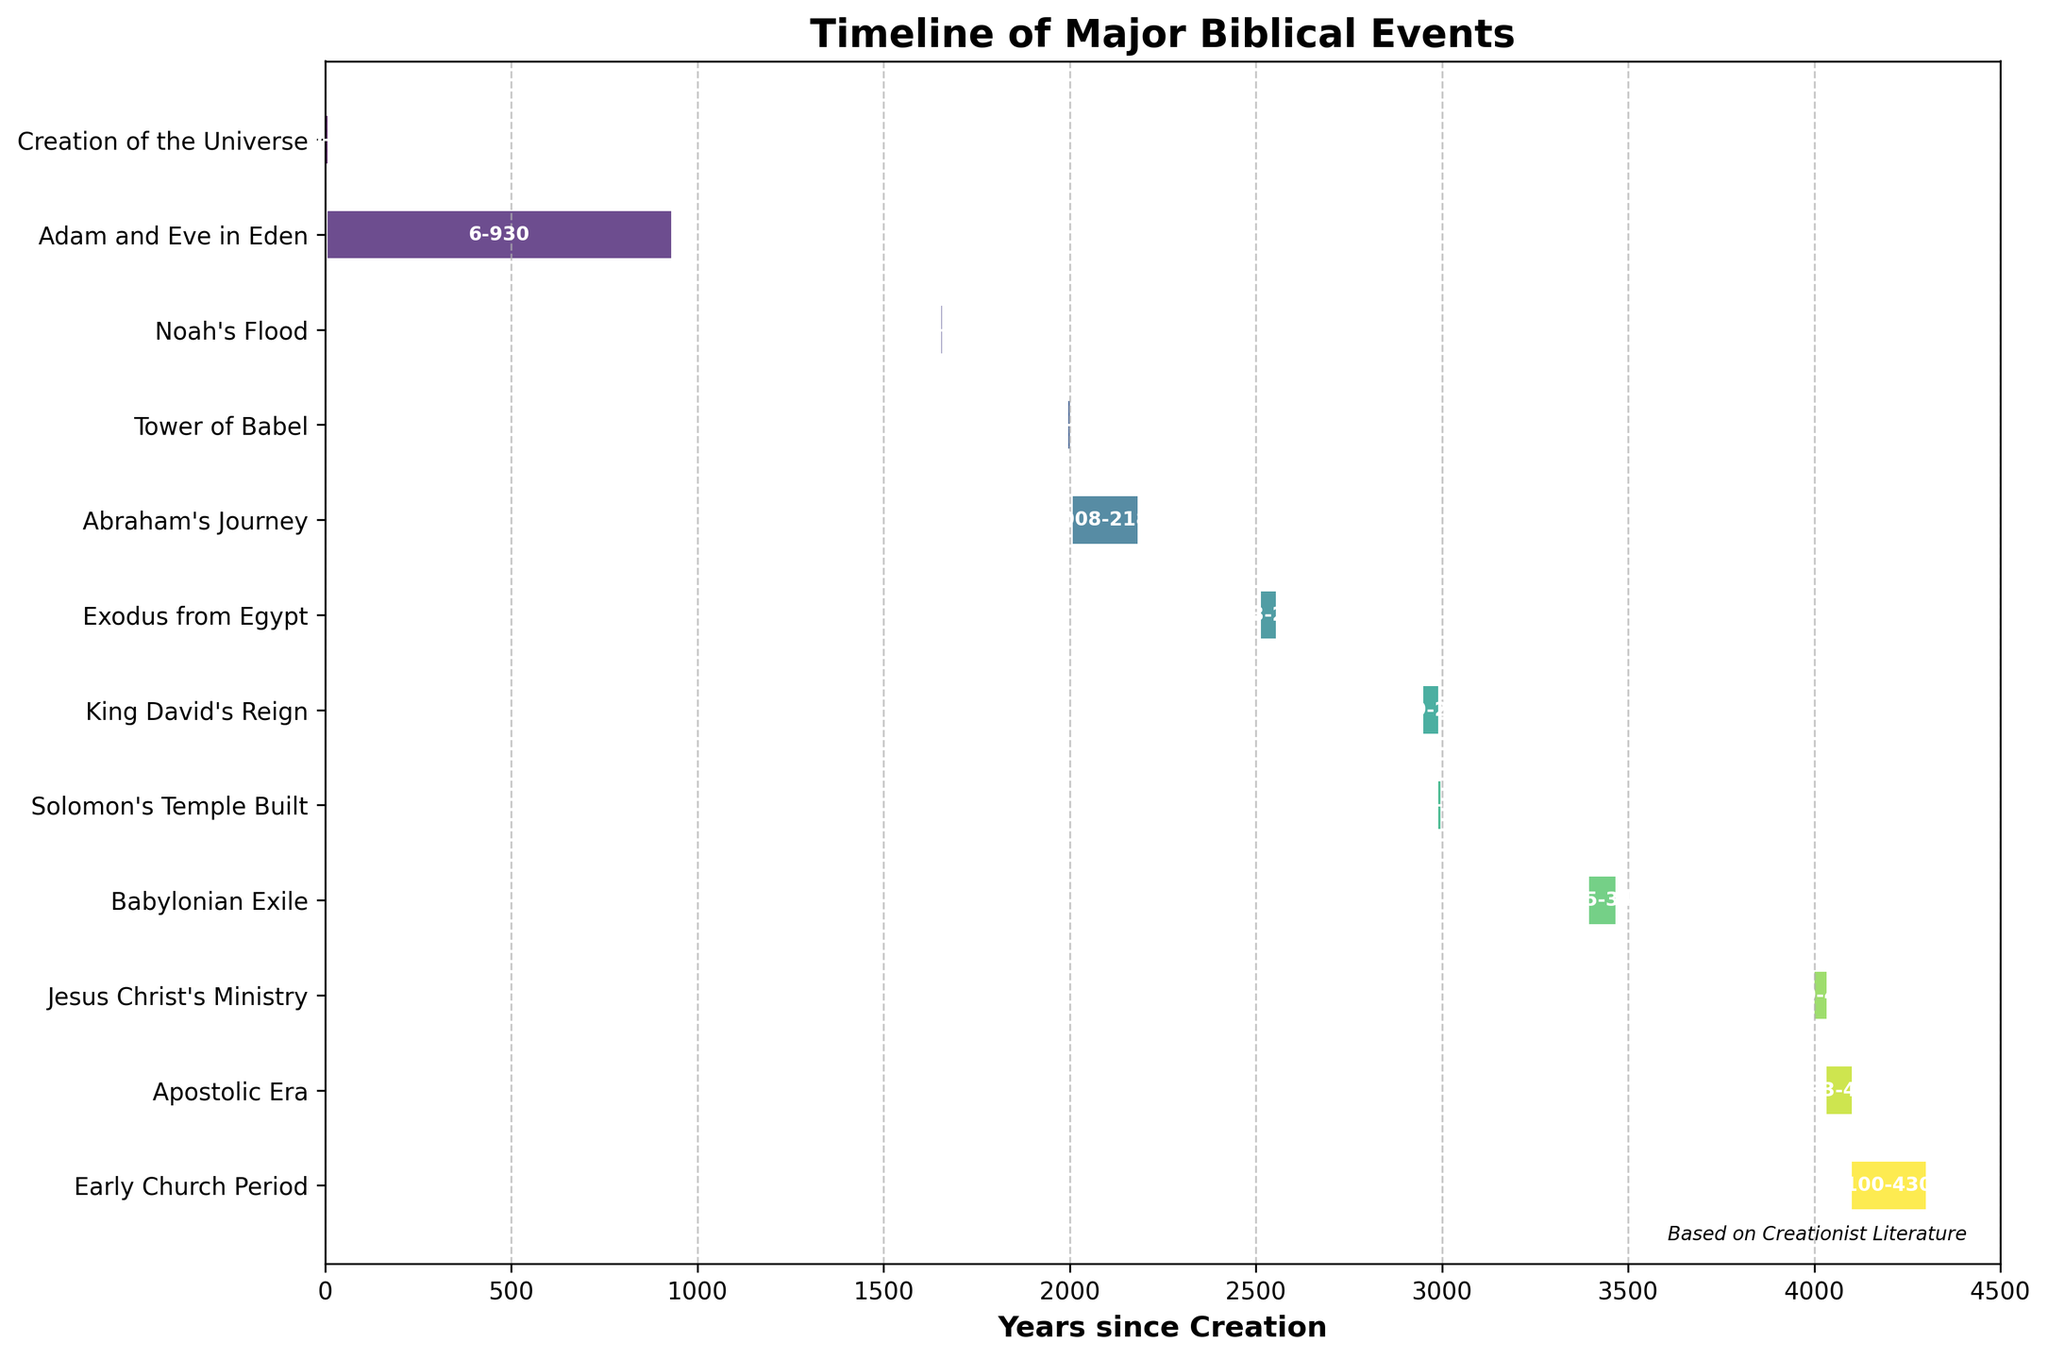What's the title of the chart? The chart's title is visible at the top of the figure.
Answer: Timeline of Major Biblical Events What are the labels of the X-axis in the chart? The X-axis label is found below the horizontal axis of the figure.
Answer: Years since Creation Which event has the longest duration depicted in the chart? Find the event bar that spans the greatest length from start to end on the X-axis.
Answer: Adam and Eve in Eden When did "Jesus Christ's Ministry" begin according to the chart? Locate the "Jesus Christ's Ministry" bar and note its starting point on the X-axis.
Answer: 4000 Between which years did the Babylonian Exile occur? Look at the start and end points of the "Babylonian Exile" bar on the X-axis.
Answer: 3395-3465 What is the total duration represented in the chart? Calculate the difference between the maximum end time and the starting year on the X-axis.
Answer: 4300 How many events are depicted in the chart? Count the number of bars/events listed on the Y-axis.
Answer: 12 Which event has the shortest duration depicted in the chart? Identify the event bar with the smallest span from start to end on the X-axis.
Answer: Noah's Flood How many years elapsed between "Creation of the Universe" and the start of "King David's Reign"? Find the ending year of the "Creation of the Universe” and the starting year of the "King David's Reign", then subtract the former from the latter.
Answer: 2949 - 6 = 2943 Compare the duration of "Exodus from Egypt" and "Early Church Period". Which one lasted longer and by how many years? Find the duration of each event by subtracting the start year from the end year, then compare the results. ("Exodus from Egypt": 2553 - 2513 = 40, "Early Church Period": 4300 - 4100 = 200)
Answer: Early Church Period lasted longer by 160 years 